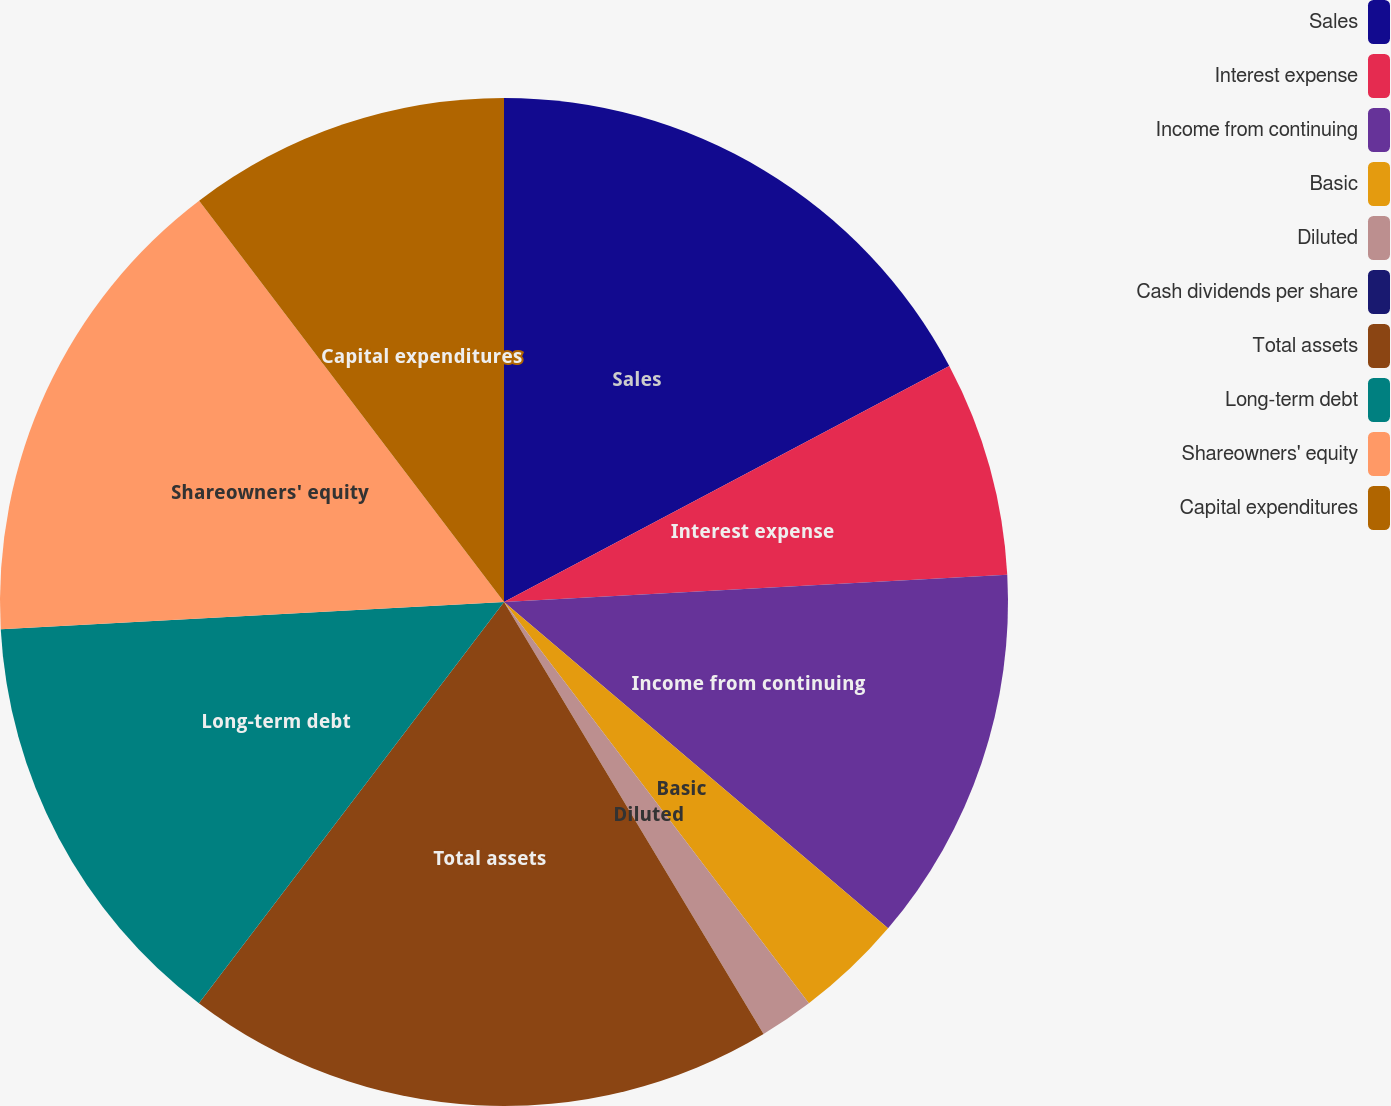Convert chart. <chart><loc_0><loc_0><loc_500><loc_500><pie_chart><fcel>Sales<fcel>Interest expense<fcel>Income from continuing<fcel>Basic<fcel>Diluted<fcel>Cash dividends per share<fcel>Total assets<fcel>Long-term debt<fcel>Shareowners' equity<fcel>Capital expenditures<nl><fcel>17.24%<fcel>6.9%<fcel>12.07%<fcel>3.45%<fcel>1.73%<fcel>0.0%<fcel>18.96%<fcel>13.79%<fcel>15.52%<fcel>10.34%<nl></chart> 